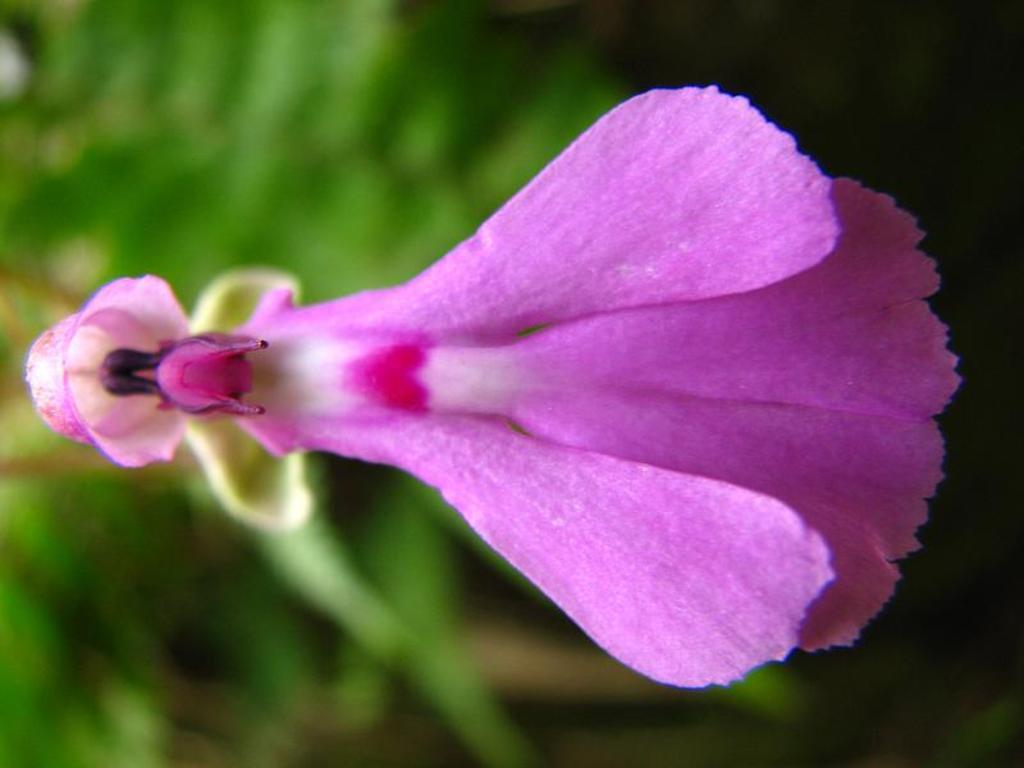Please provide a concise description of this image. In the center of the image, we can see a flower which is in purple color and in the background, there are trees. 